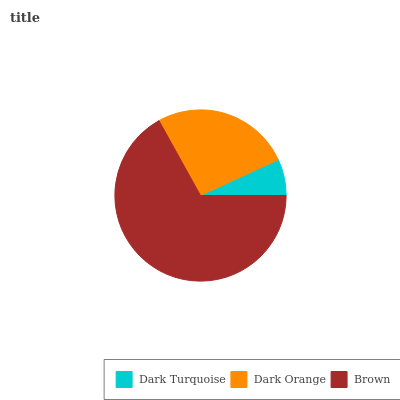Is Dark Turquoise the minimum?
Answer yes or no. Yes. Is Brown the maximum?
Answer yes or no. Yes. Is Dark Orange the minimum?
Answer yes or no. No. Is Dark Orange the maximum?
Answer yes or no. No. Is Dark Orange greater than Dark Turquoise?
Answer yes or no. Yes. Is Dark Turquoise less than Dark Orange?
Answer yes or no. Yes. Is Dark Turquoise greater than Dark Orange?
Answer yes or no. No. Is Dark Orange less than Dark Turquoise?
Answer yes or no. No. Is Dark Orange the high median?
Answer yes or no. Yes. Is Dark Orange the low median?
Answer yes or no. Yes. Is Brown the high median?
Answer yes or no. No. Is Brown the low median?
Answer yes or no. No. 